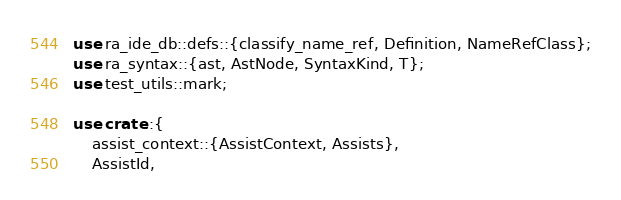<code> <loc_0><loc_0><loc_500><loc_500><_Rust_>use ra_ide_db::defs::{classify_name_ref, Definition, NameRefClass};
use ra_syntax::{ast, AstNode, SyntaxKind, T};
use test_utils::mark;

use crate::{
    assist_context::{AssistContext, Assists},
    AssistId,</code> 